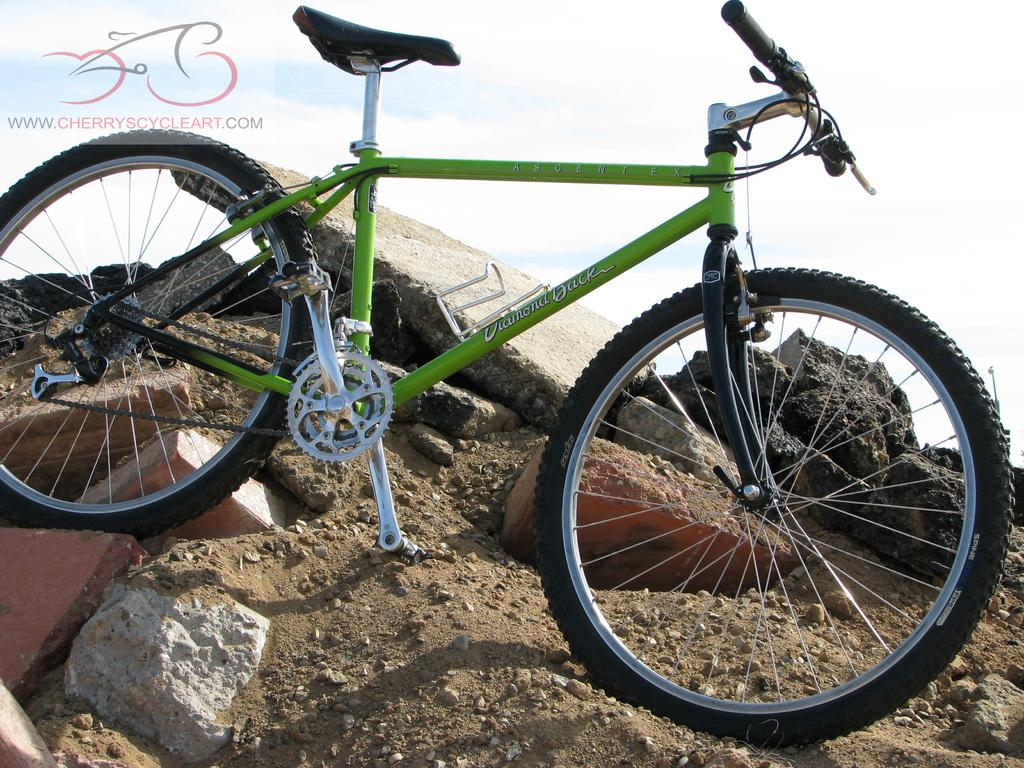What is the main subject of the picture? The main subject of the picture is a bicycle. What color is the bicycle? The bicycle is green in color. Where is the bicycle placed in the picture? The bicycle is placed on a mud hill. What can be seen on the mud hill besides the bicycle? There are stones on the mud hill. What is visible in the background of the picture? The sky is visible in the background of the picture. What can be observed in the sky? Clouds are present in the sky. What type of wax is being applied to the bicycle in the image? There is no wax being applied to the bicycle in the image; it is simply placed on a mud hill. What kind of experience does the person riding the bicycle have in the image? There is no person riding the bicycle in the image, so it is not possible to determine their experience. 